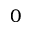<formula> <loc_0><loc_0><loc_500><loc_500>0</formula> 